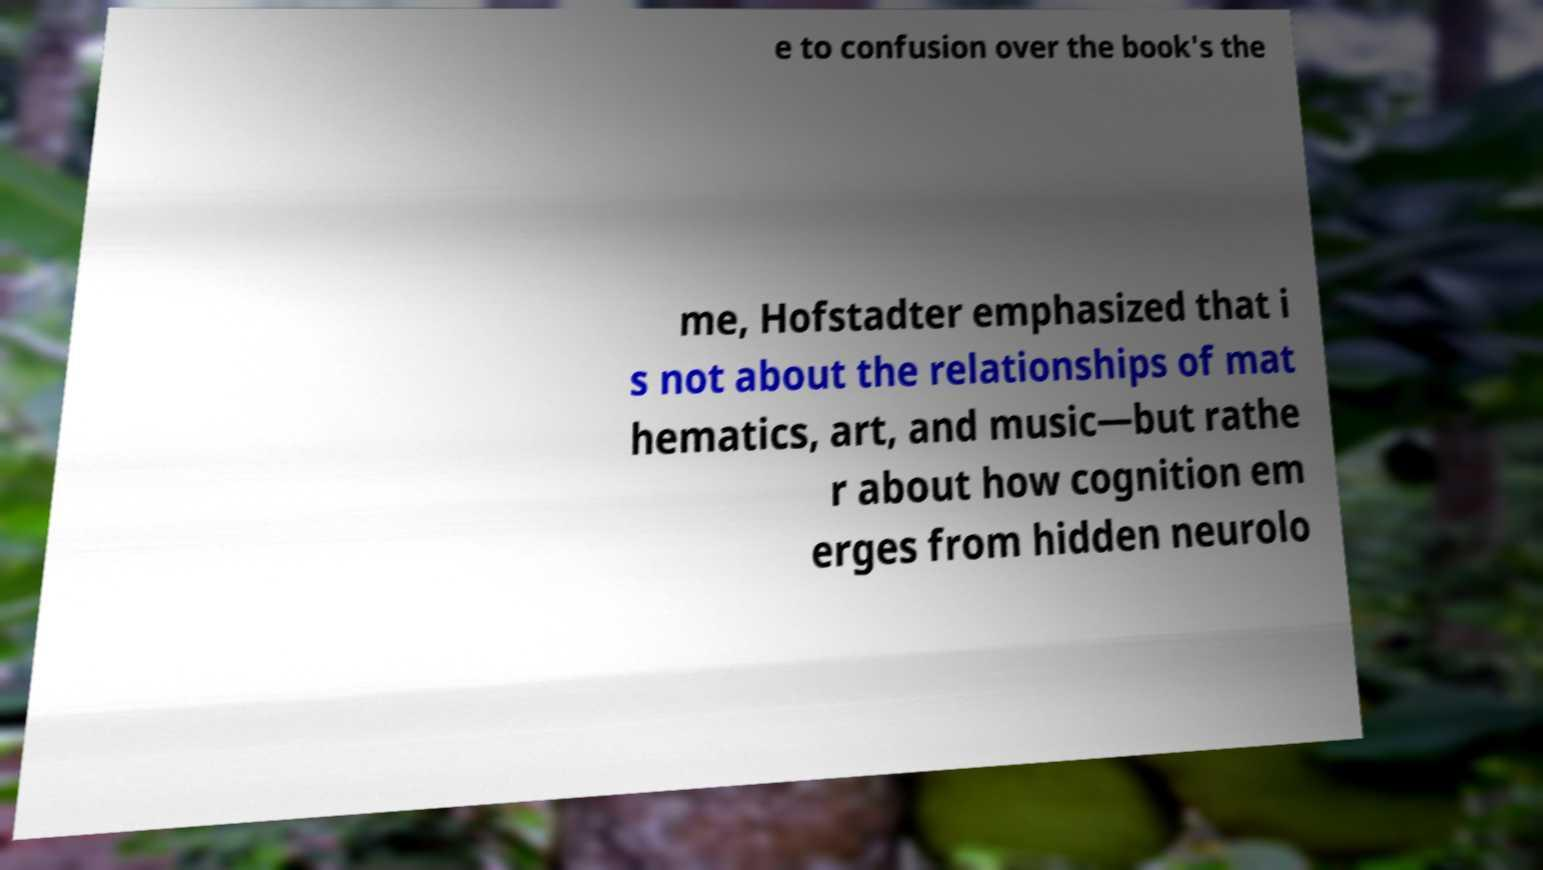Can you accurately transcribe the text from the provided image for me? e to confusion over the book's the me, Hofstadter emphasized that i s not about the relationships of mat hematics, art, and music—but rathe r about how cognition em erges from hidden neurolo 